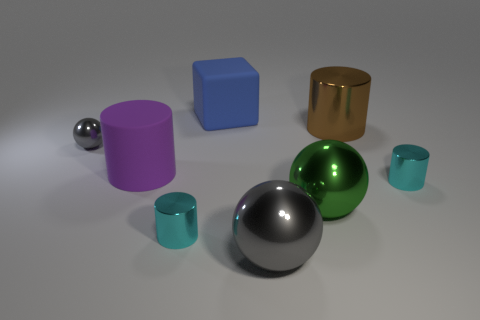Are there any other things that have the same shape as the big blue matte object?
Ensure brevity in your answer.  No. Are there the same number of gray objects that are behind the large purple rubber cylinder and large cyan metal balls?
Keep it short and to the point. No. There is a thing that is the same color as the tiny shiny ball; what material is it?
Your response must be concise. Metal. There is a purple object; is it the same size as the cyan metal thing on the right side of the blue block?
Your answer should be very brief. No. How many other objects are the same size as the brown metal object?
Your answer should be compact. 4. What number of other objects are the same color as the small ball?
Provide a short and direct response. 1. What number of other things are there of the same shape as the blue rubber object?
Give a very brief answer. 0. Are any large brown metal things visible?
Provide a short and direct response. Yes. Is there a small cyan object that has the same material as the big green thing?
Your answer should be very brief. Yes. There is a gray thing that is the same size as the purple object; what material is it?
Your answer should be compact. Metal. 